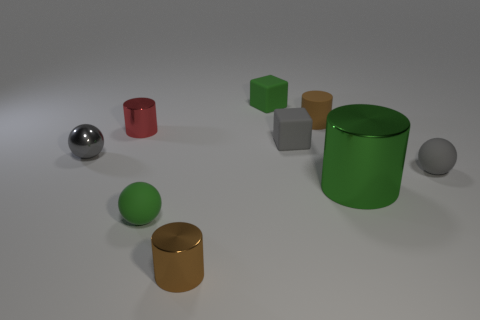Subtract all small matte cylinders. How many cylinders are left? 3 Subtract all gray balls. How many balls are left? 1 Add 1 small green matte balls. How many objects exist? 10 Subtract all blocks. How many objects are left? 7 Subtract 4 cylinders. How many cylinders are left? 0 Subtract all green cubes. How many green balls are left? 1 Subtract 1 gray blocks. How many objects are left? 8 Subtract all gray blocks. Subtract all red balls. How many blocks are left? 1 Subtract all small matte cylinders. Subtract all tiny green balls. How many objects are left? 7 Add 4 matte spheres. How many matte spheres are left? 6 